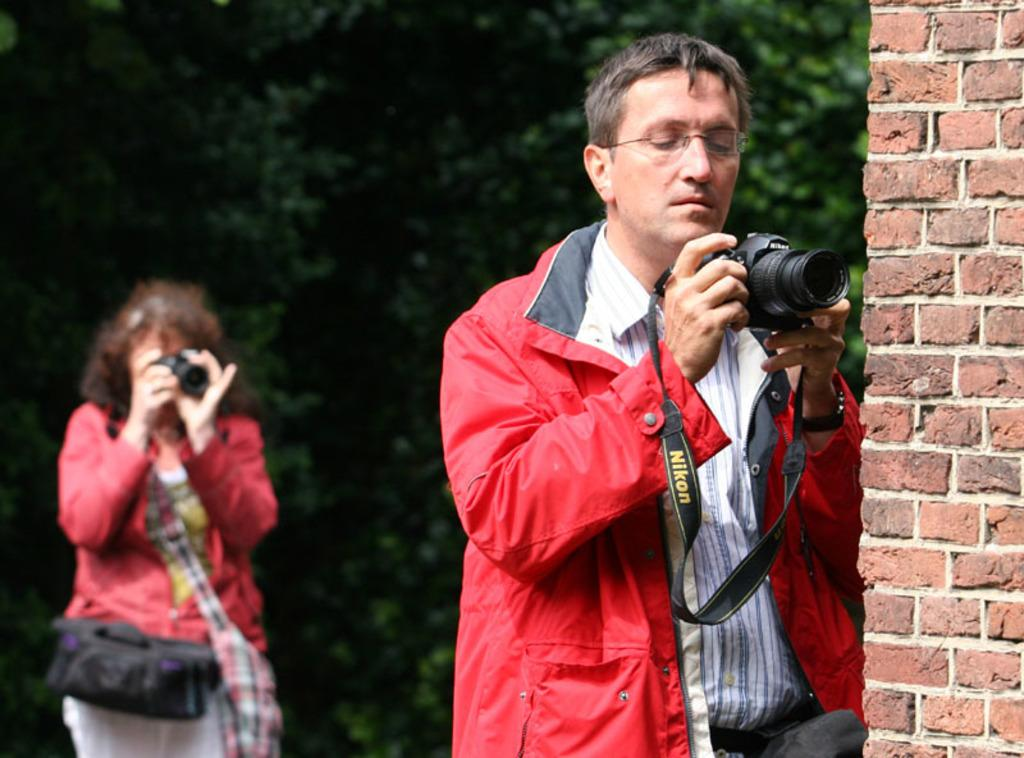How many people are in the image? There are two people in the image. What are the people wearing? Both people are wearing red jackets. What are the people doing in the image? The people are using cameras and clicking images. What can be seen in the background of the image? There are trees in the background of the image. What type of metal is the surprise made of in the image? There is no surprise or metal present in the image; it features two people using cameras and wearing red jackets. 